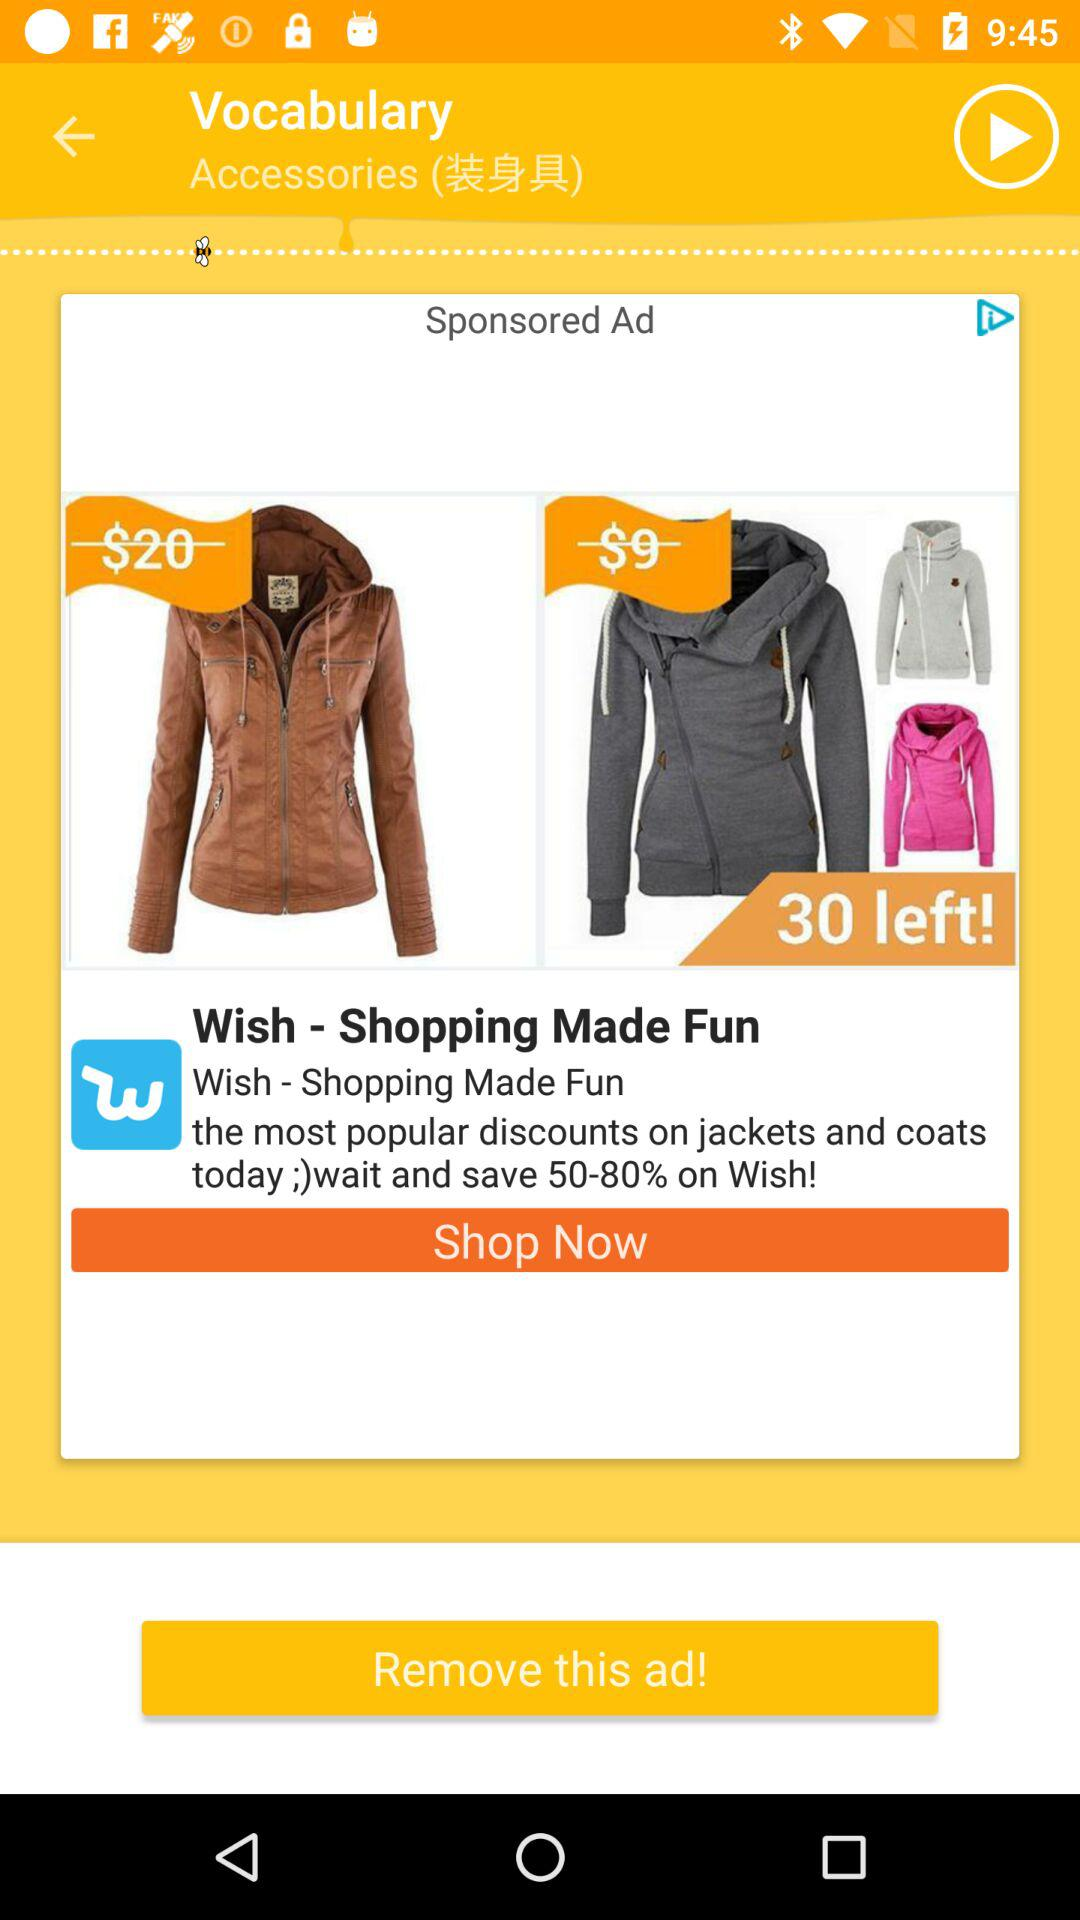How much more expensive is the first jacket than the second jacket?
Answer the question using a single word or phrase. $11 